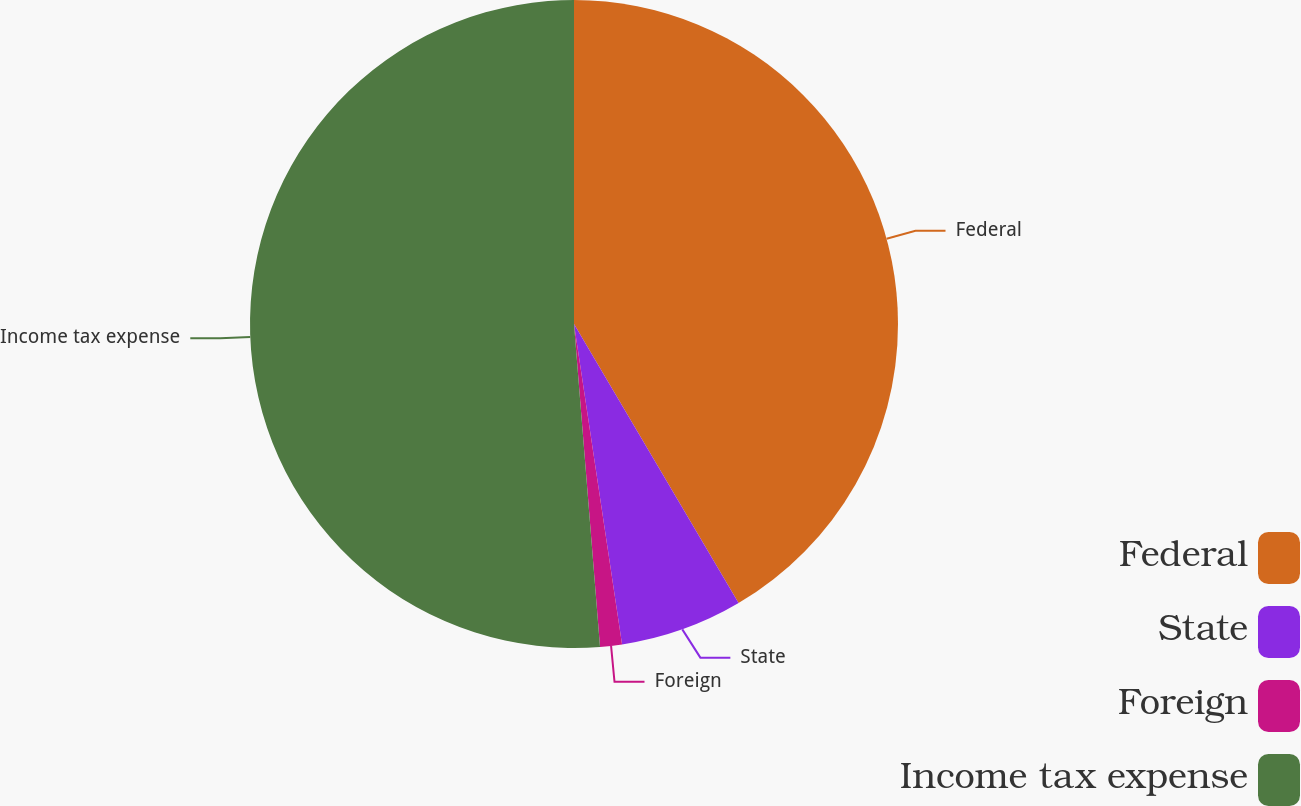<chart> <loc_0><loc_0><loc_500><loc_500><pie_chart><fcel>Federal<fcel>State<fcel>Foreign<fcel>Income tax expense<nl><fcel>41.52%<fcel>6.11%<fcel>1.09%<fcel>51.28%<nl></chart> 